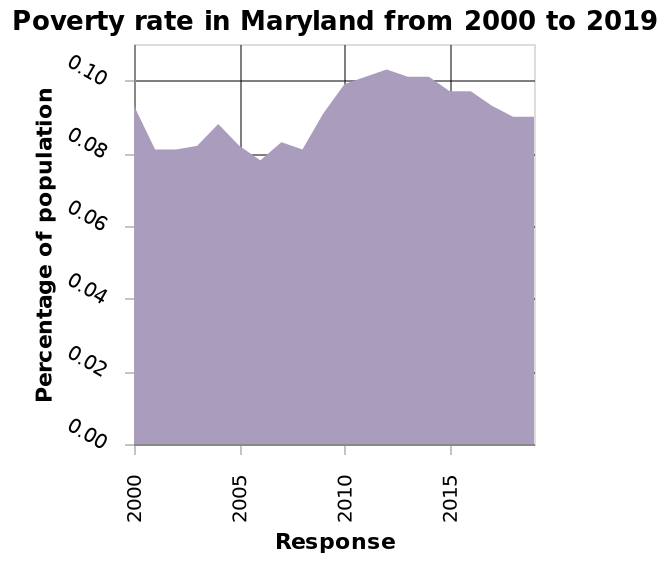<image>
What is the trend of the data from approximately 2012 onwards? The trend decreases from approximately 2012 onwards. What is the title of the area diagram?  The title of the area diagram is "Poverty rate in Maryland from 2000 to 2019." please describe the details of the chart Here a area diagram is called Poverty rate in Maryland from 2000 to 2019. The y-axis shows Percentage of population on linear scale of range 0.00 to 0.10 while the x-axis measures Response using linear scale with a minimum of 2000 and a maximum of 2015. 